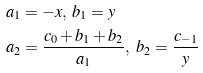<formula> <loc_0><loc_0><loc_500><loc_500>& a _ { 1 } = - x , \ b _ { 1 } = y \\ & a _ { 2 } = \frac { c _ { 0 } + b _ { 1 } + b _ { 2 } } { a _ { 1 } } , \ b _ { 2 } = \frac { c _ { - 1 } } { y }</formula> 